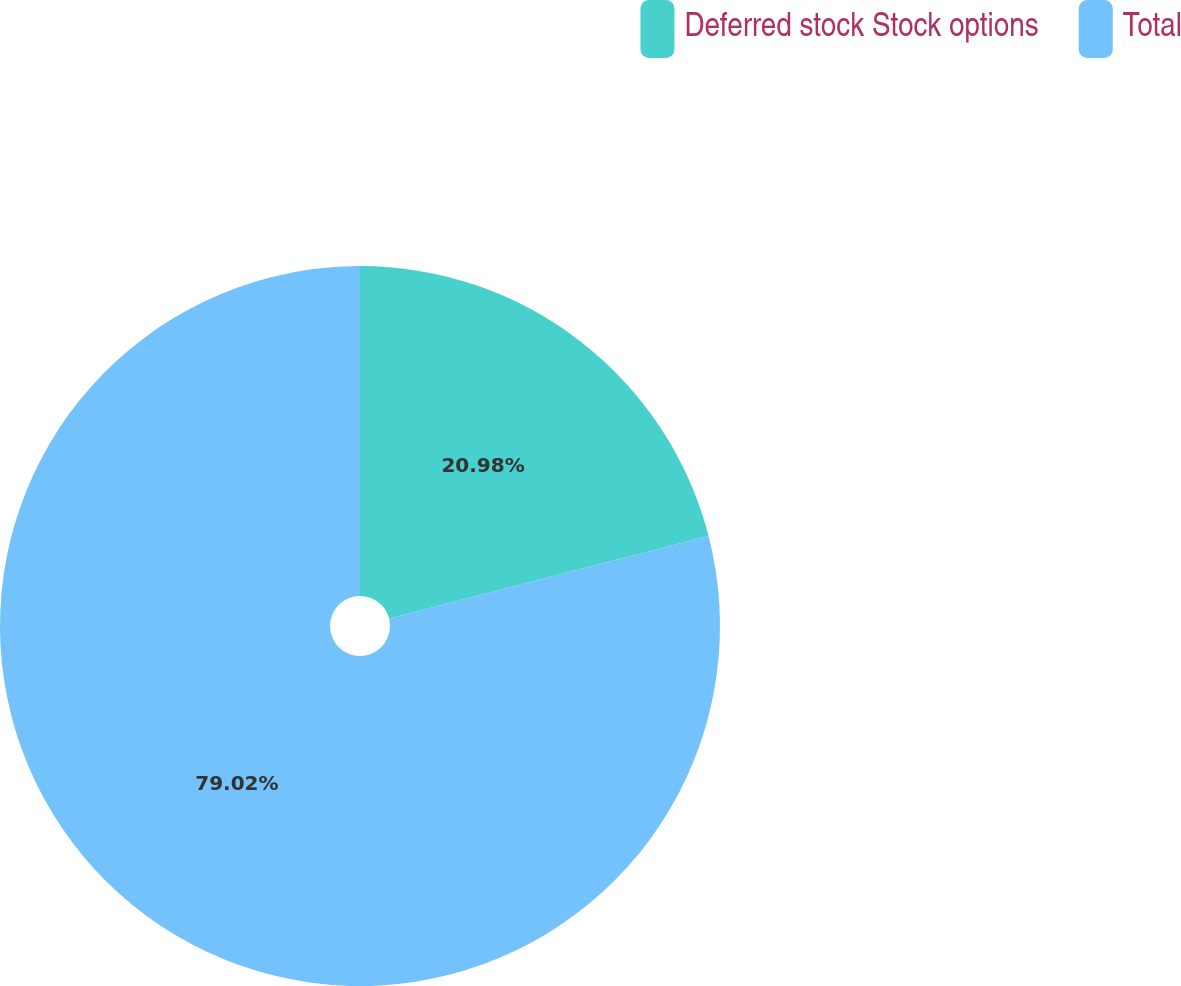Convert chart. <chart><loc_0><loc_0><loc_500><loc_500><pie_chart><fcel>Deferred stock Stock options<fcel>Total<nl><fcel>20.98%<fcel>79.02%<nl></chart> 